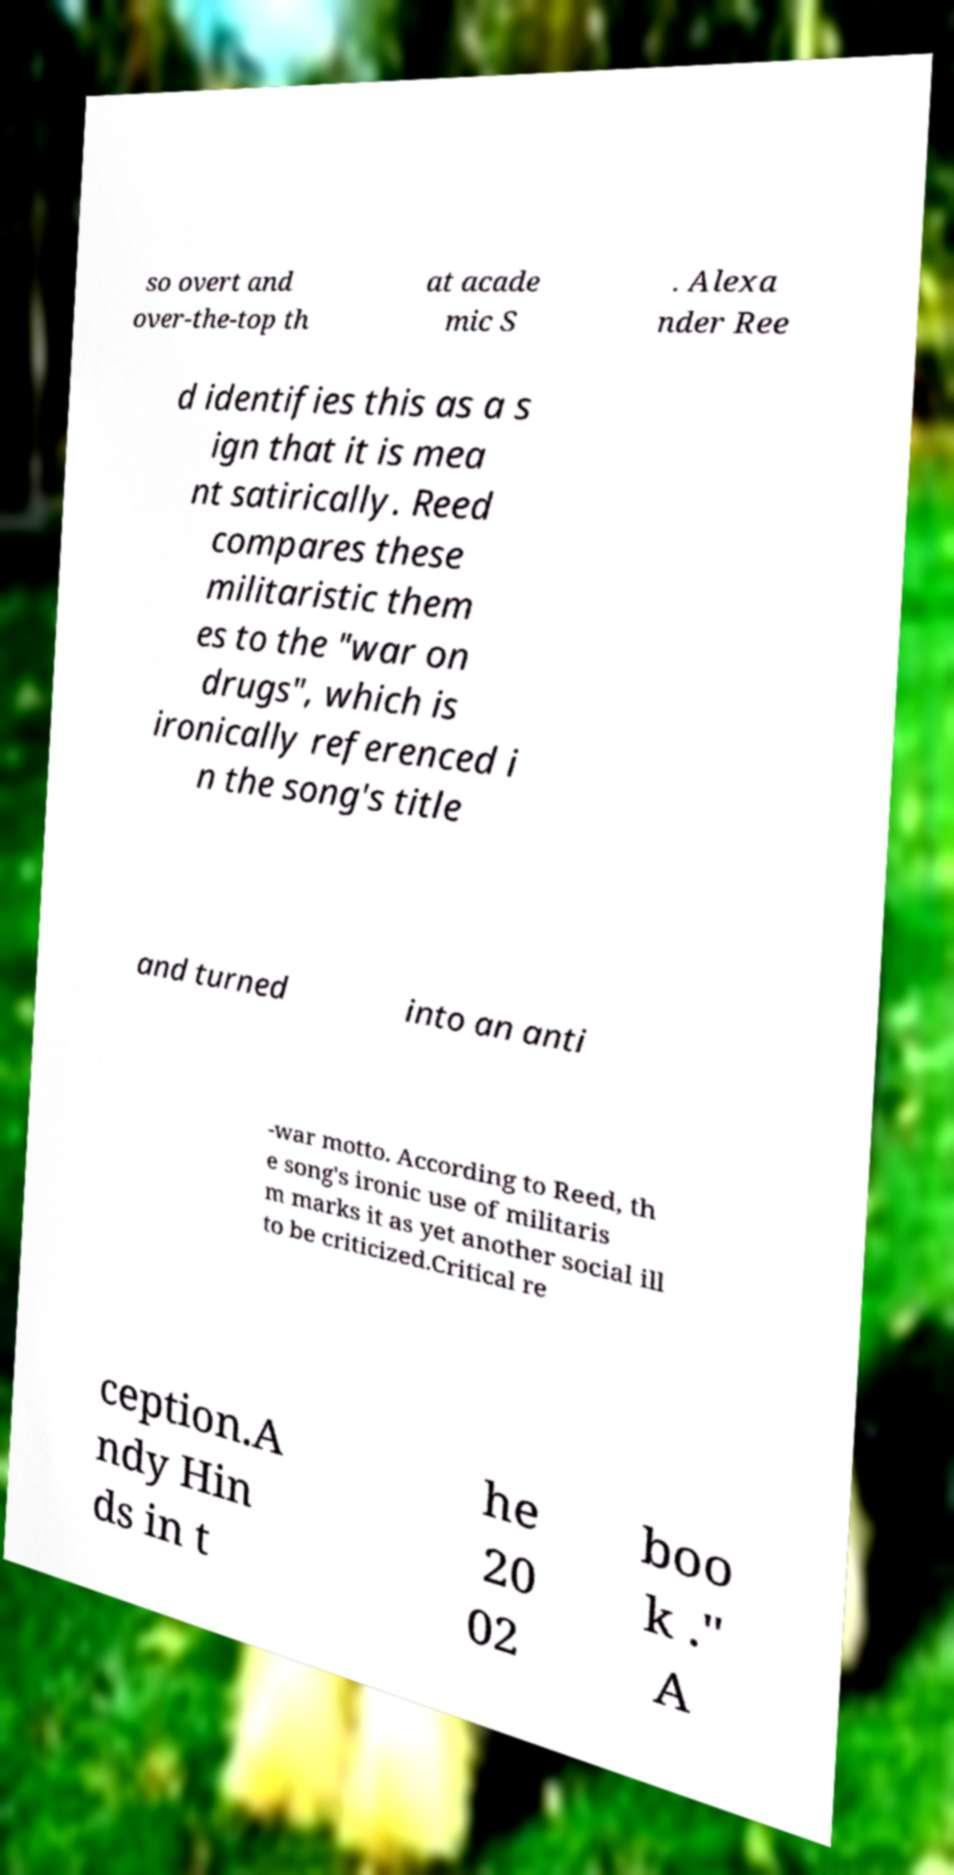For documentation purposes, I need the text within this image transcribed. Could you provide that? so overt and over-the-top th at acade mic S . Alexa nder Ree d identifies this as a s ign that it is mea nt satirically. Reed compares these militaristic them es to the "war on drugs", which is ironically referenced i n the song's title and turned into an anti -war motto. According to Reed, th e song's ironic use of militaris m marks it as yet another social ill to be criticized.Critical re ception.A ndy Hin ds in t he 20 02 boo k ." A 